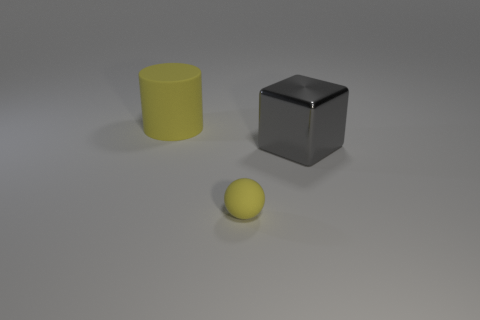How do the textures of the objects compare? The objects appear to have matte textures, which means they do not reflect light harshly and have a non-glossy finish. This type of texture helps to evenly distribute the light, softening the appearance of the surfaces. 